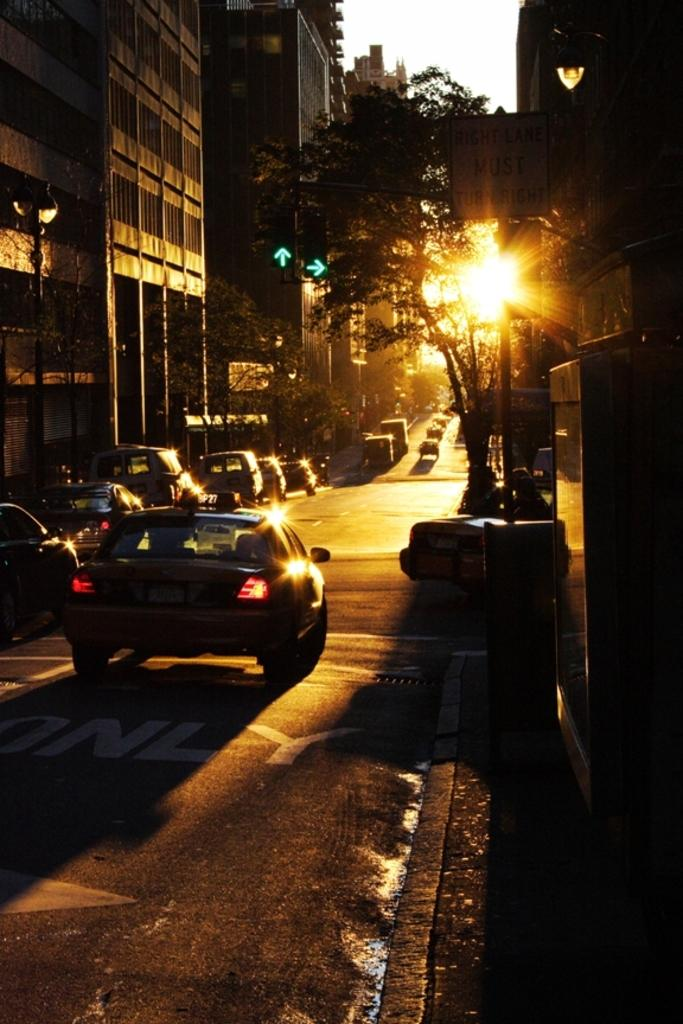What is present on the road in the image? There is a group of vehicles on the road in the image. What structures can be seen in the image? There are poles, buildings, and a traffic signal visible in the image. What type of illumination is present in the image? There are lights visible in the image. What type of natural elements can be seen in the image? Trees are visible in the image. What part of the natural environment is visible in the image? The sky is visible in the image. What type of shoes are hanging from the traffic signal in the image? There are no shoes present in the image, and therefore no such activity can be observed. What type of bun is being served at the restaurant in the image? There is no restaurant or bun present in the image. 